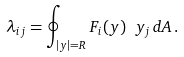<formula> <loc_0><loc_0><loc_500><loc_500>\lambda _ { i j } = \oint _ { | { y } | = R } F _ { i } ( { y } ) \ y _ { j } \, d A \, .</formula> 